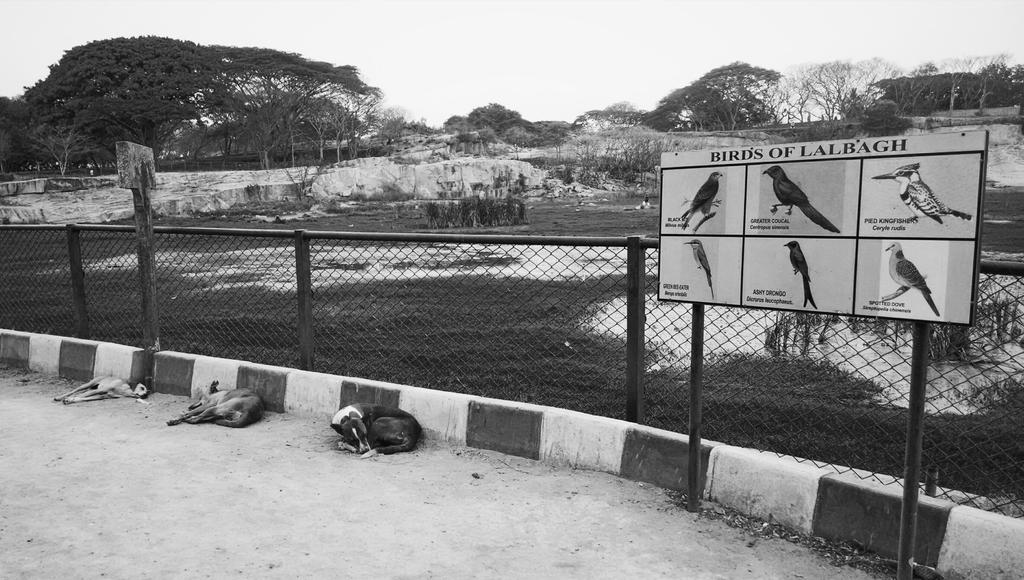What is located in the foreground of the image? There is a path in the foreground of the image. How many dogs are present in the image? There are three dogs in the image. What type of barrier can be seen in the image? There is fencing in the image. What other objects are present in the image? There are boards and a rock in the image. What type of vegetation is visible in the image? There are trees in the image. What part of the natural environment is visible in the image? The sky is visible in the image. What type of order are the dogs following in the image? There is no indication of an order or sequence in the image; the dogs are simply present. What is the dogs' desire in the image? There is no indication of the dogs' desires in the image; they are simply present. 